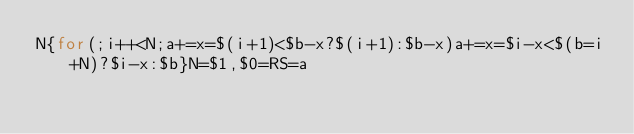<code> <loc_0><loc_0><loc_500><loc_500><_Awk_>N{for(;i++<N;a+=x=$(i+1)<$b-x?$(i+1):$b-x)a+=x=$i-x<$(b=i+N)?$i-x:$b}N=$1,$0=RS=a</code> 